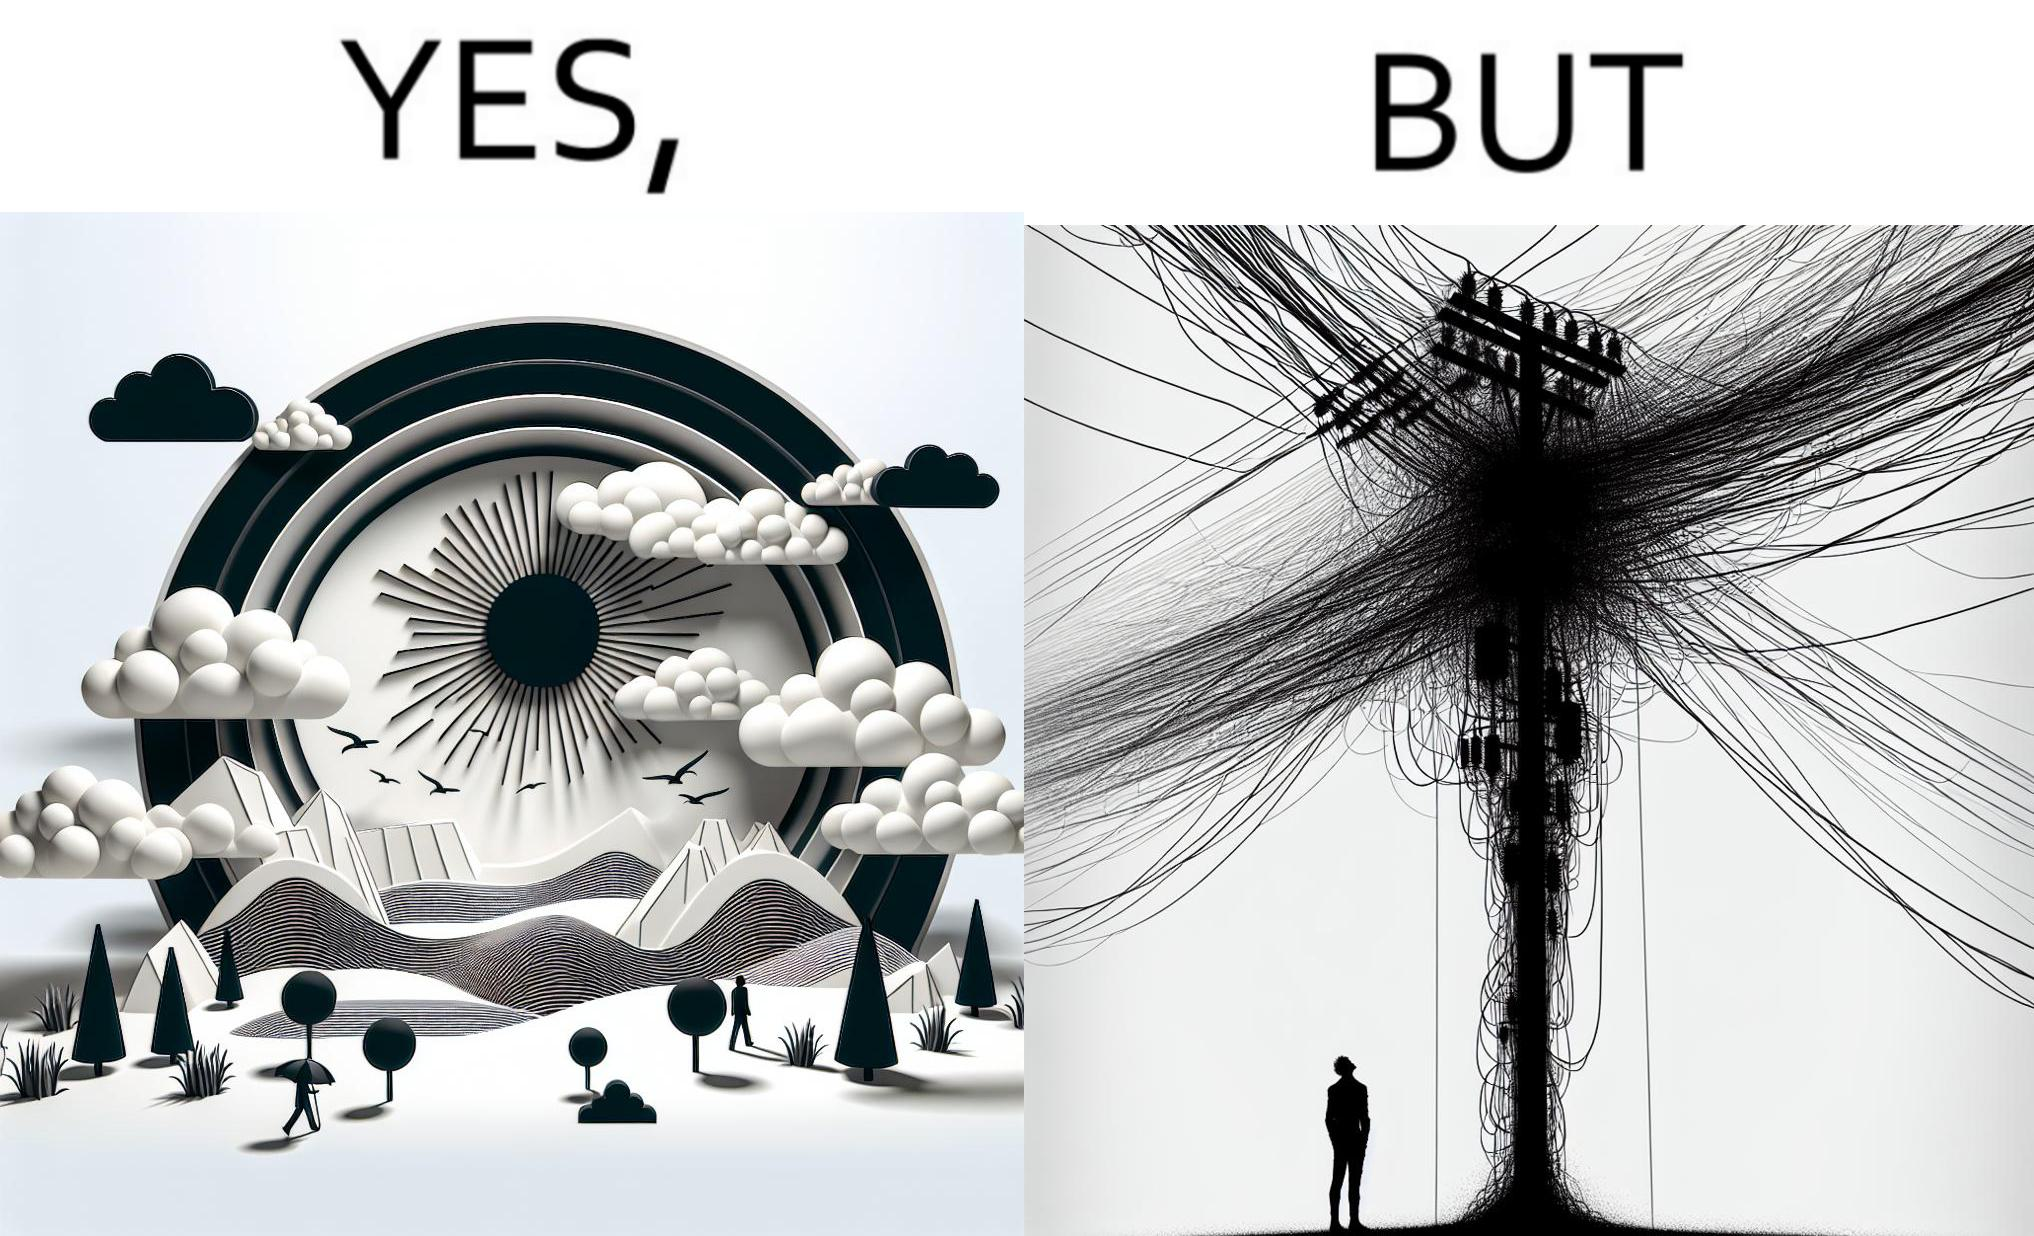Provide a description of this image. The image is ironic, because in the first image clear sky is visible but in the second image the same view is getting blocked due to the electricity pole 